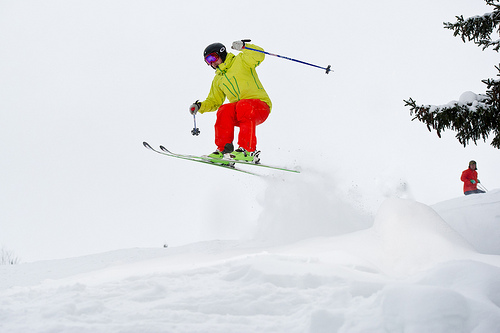Please provide the bounding box coordinate of the region this sentence describes: snow is on the tree. A layer of fresh snow clings to the branches of the tree, outlined by the bounding box [0.82, 0.34, 0.98, 0.45]. 